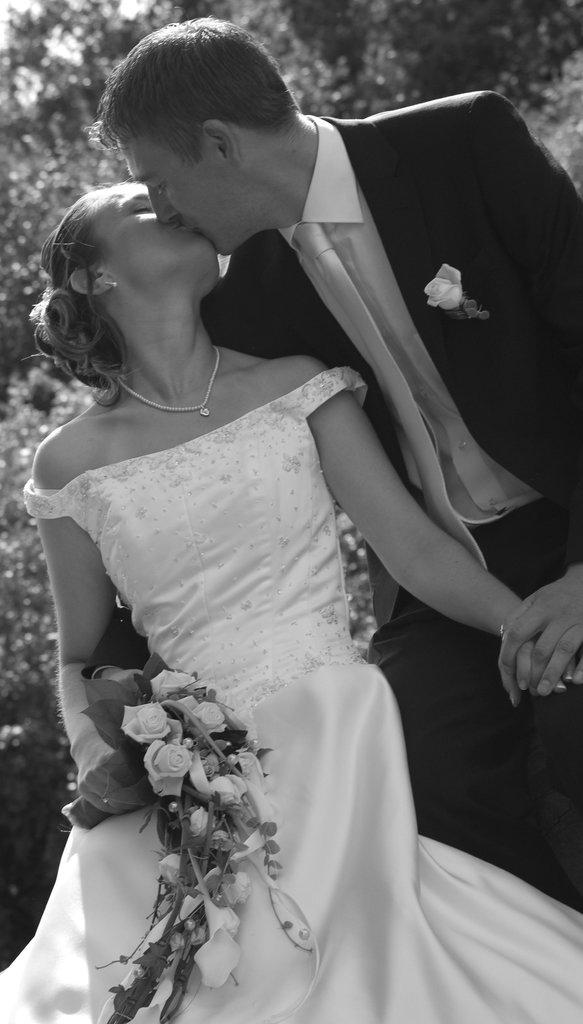What is the color scheme of the image? The image is black and white. How many people are present in the image? There is a man and a woman in the image. What is the woman holding in the image? The woman is holding a flower bouquet. What can be seen in the background of the image? There are trees in the background of the image. What type of appliance is the man using to make a request in the image? There is no appliance present in the image, and the man is not making any requests. How many eyes can be seen on the woman in the image? The image is black and white, so it is difficult to determine the number of eyes on the woman. However, typically, humans have two eyes, and there is no indication in the image that the woman has more or fewer than two eyes. 